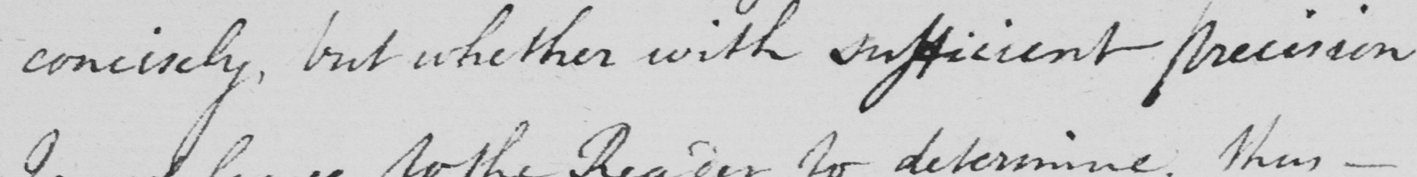What is written in this line of handwriting? concisely , but whether with sufficient precision 